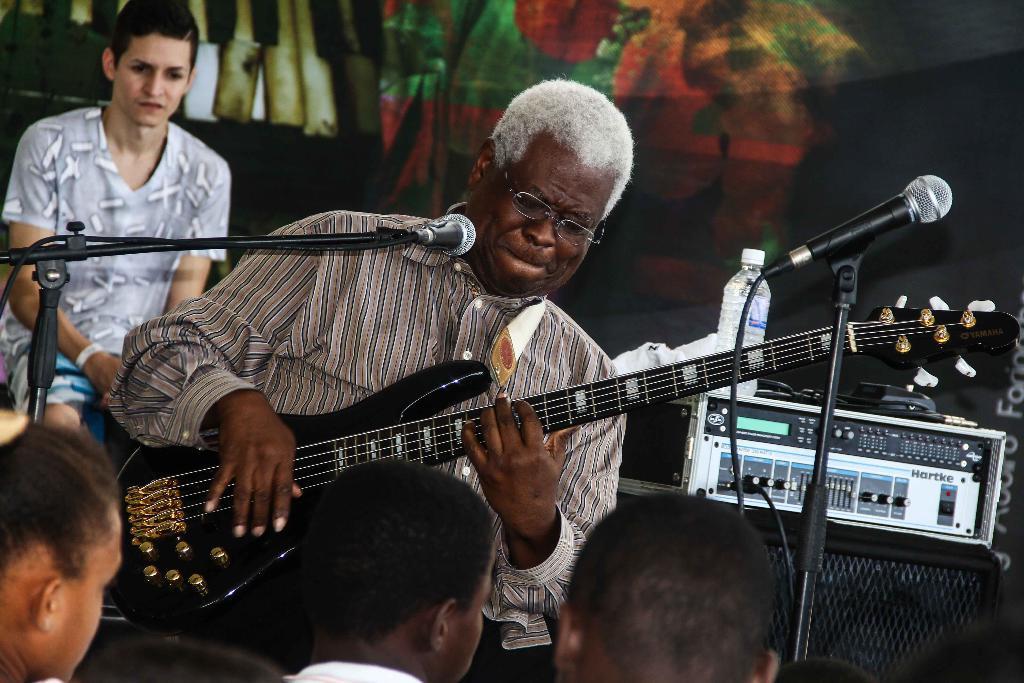Describe this image in one or two sentences. This is the man standing and playing guitar. This is the man sitting. These are the mics attached to the mike stand. This looks like an electronic device. I can see a water bottle placed on the device. I think this is a speaker,background looks colorful. There are three more people at the bottom of the image. 